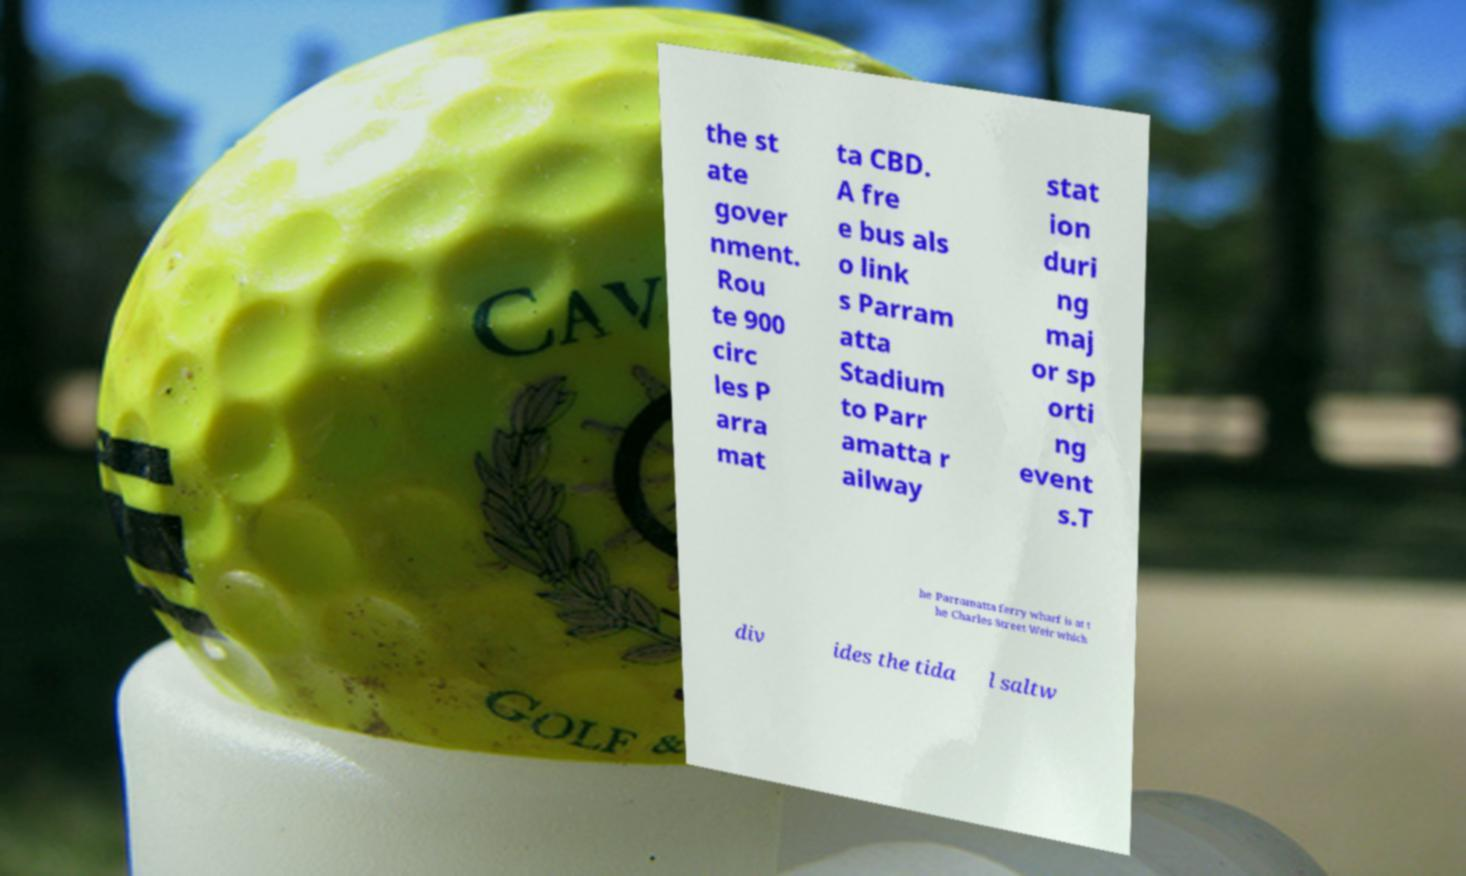Can you accurately transcribe the text from the provided image for me? the st ate gover nment. Rou te 900 circ les P arra mat ta CBD. A fre e bus als o link s Parram atta Stadium to Parr amatta r ailway stat ion duri ng maj or sp orti ng event s.T he Parramatta ferry wharf is at t he Charles Street Weir which div ides the tida l saltw 